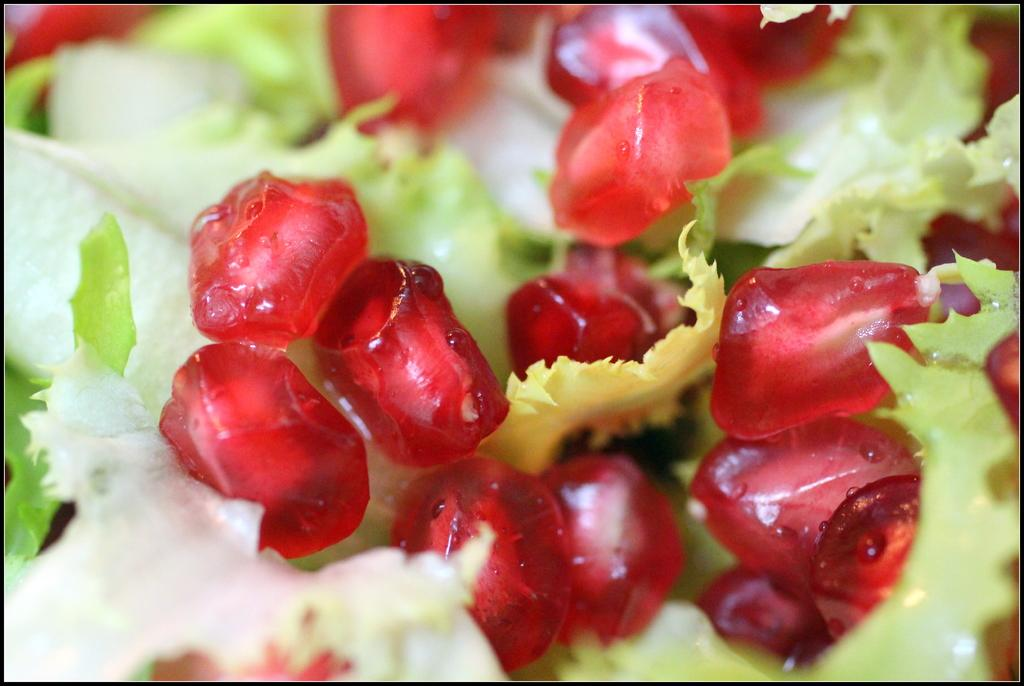What is the main object in the picture? There is a dish in the picture. What is inside the dish? The dish contains pomegranates. Are there any other items in the dish besides pomegranates? Yes, there are other items in the dish. What is the rate of religious horse racing in the image? There is no mention of religious horse racing or any horses in the image. The image only features a dish with pomegranates and other items. 